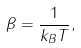<formula> <loc_0><loc_0><loc_500><loc_500>\beta = \frac { 1 } { k _ { B } T } ,</formula> 